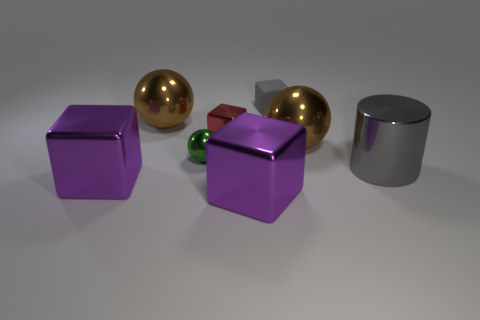Do the matte cube and the red shiny object have the same size?
Provide a short and direct response. Yes. There is a object in front of the big purple object that is to the left of the red cube; what color is it?
Provide a short and direct response. Purple. What is the color of the small metallic cube?
Offer a terse response. Red. Are there any big metal blocks of the same color as the big cylinder?
Give a very brief answer. No. Is the color of the tiny cube that is in front of the small gray matte cube the same as the big cylinder?
Offer a very short reply. No. How many objects are either small green metallic things that are behind the gray cylinder or green metal objects?
Provide a succinct answer. 1. There is a green metallic object; are there any big brown metallic objects in front of it?
Ensure brevity in your answer.  No. There is a large object that is the same color as the rubber block; what material is it?
Ensure brevity in your answer.  Metal. Is the material of the gray object in front of the tiny gray rubber object the same as the tiny green thing?
Offer a very short reply. Yes. Are there any small red metallic blocks in front of the brown metal sphere to the right of the gray object on the left side of the large gray cylinder?
Provide a short and direct response. No. 